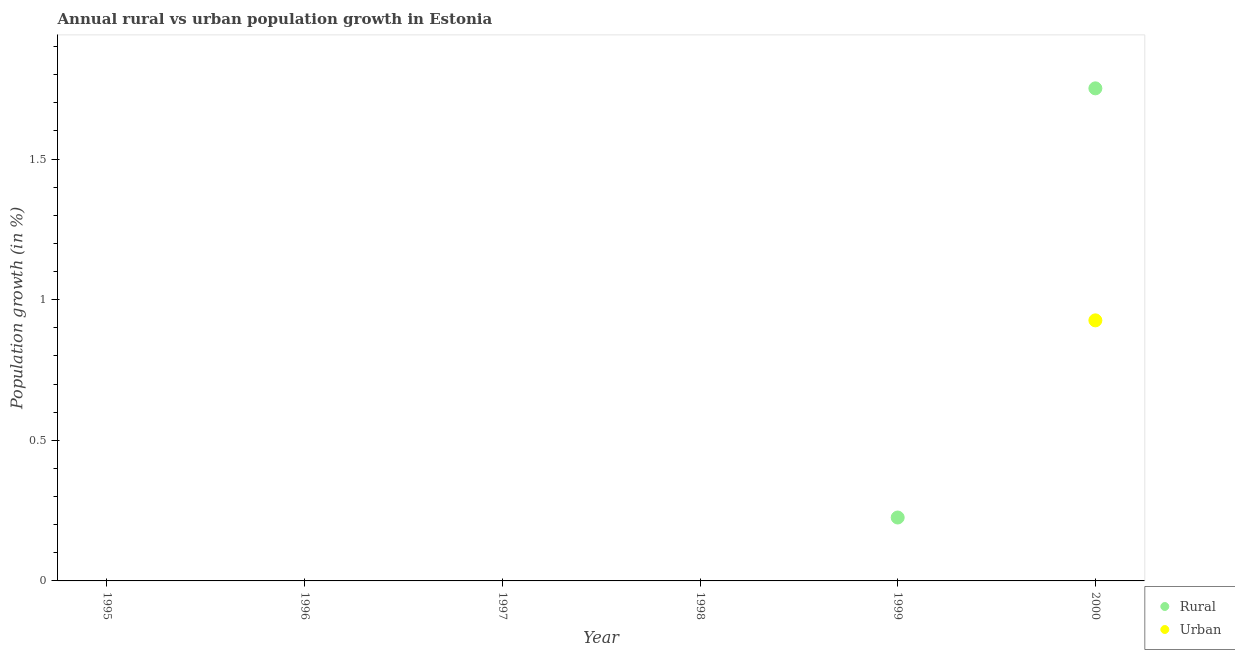How many different coloured dotlines are there?
Offer a very short reply. 2. What is the urban population growth in 1997?
Provide a succinct answer. 0. Across all years, what is the maximum urban population growth?
Your answer should be compact. 0.93. In which year was the urban population growth maximum?
Make the answer very short. 2000. What is the total rural population growth in the graph?
Your response must be concise. 1.98. What is the difference between the rural population growth in 1999 and that in 2000?
Your response must be concise. -1.53. What is the difference between the urban population growth in 1999 and the rural population growth in 2000?
Provide a succinct answer. -1.75. What is the average urban population growth per year?
Provide a short and direct response. 0.15. In the year 2000, what is the difference between the rural population growth and urban population growth?
Keep it short and to the point. 0.82. What is the difference between the highest and the lowest rural population growth?
Your answer should be compact. 1.75. In how many years, is the rural population growth greater than the average rural population growth taken over all years?
Offer a terse response. 1. Does the urban population growth monotonically increase over the years?
Give a very brief answer. Yes. Is the urban population growth strictly less than the rural population growth over the years?
Your response must be concise. Yes. How many dotlines are there?
Provide a short and direct response. 2. How many years are there in the graph?
Offer a terse response. 6. Does the graph contain grids?
Your answer should be compact. No. What is the title of the graph?
Your response must be concise. Annual rural vs urban population growth in Estonia. What is the label or title of the X-axis?
Offer a terse response. Year. What is the label or title of the Y-axis?
Your answer should be very brief. Population growth (in %). What is the Population growth (in %) of Rural in 1995?
Keep it short and to the point. 0. What is the Population growth (in %) in Urban  in 1995?
Your answer should be very brief. 0. What is the Population growth (in %) in Urban  in 1996?
Give a very brief answer. 0. What is the Population growth (in %) in Rural in 1998?
Provide a succinct answer. 0. What is the Population growth (in %) of Rural in 1999?
Provide a short and direct response. 0.23. What is the Population growth (in %) of Urban  in 1999?
Give a very brief answer. 0. What is the Population growth (in %) of Rural in 2000?
Make the answer very short. 1.75. What is the Population growth (in %) in Urban  in 2000?
Offer a terse response. 0.93. Across all years, what is the maximum Population growth (in %) of Rural?
Your answer should be very brief. 1.75. Across all years, what is the maximum Population growth (in %) in Urban ?
Provide a short and direct response. 0.93. Across all years, what is the minimum Population growth (in %) of Rural?
Give a very brief answer. 0. Across all years, what is the minimum Population growth (in %) of Urban ?
Provide a short and direct response. 0. What is the total Population growth (in %) of Rural in the graph?
Offer a very short reply. 1.98. What is the total Population growth (in %) of Urban  in the graph?
Your response must be concise. 0.93. What is the difference between the Population growth (in %) of Rural in 1999 and that in 2000?
Give a very brief answer. -1.53. What is the difference between the Population growth (in %) in Rural in 1999 and the Population growth (in %) in Urban  in 2000?
Provide a succinct answer. -0.7. What is the average Population growth (in %) of Rural per year?
Keep it short and to the point. 0.33. What is the average Population growth (in %) in Urban  per year?
Provide a succinct answer. 0.15. In the year 2000, what is the difference between the Population growth (in %) in Rural and Population growth (in %) in Urban ?
Provide a succinct answer. 0.82. What is the ratio of the Population growth (in %) in Rural in 1999 to that in 2000?
Make the answer very short. 0.13. What is the difference between the highest and the lowest Population growth (in %) in Rural?
Ensure brevity in your answer.  1.75. What is the difference between the highest and the lowest Population growth (in %) of Urban ?
Provide a short and direct response. 0.93. 